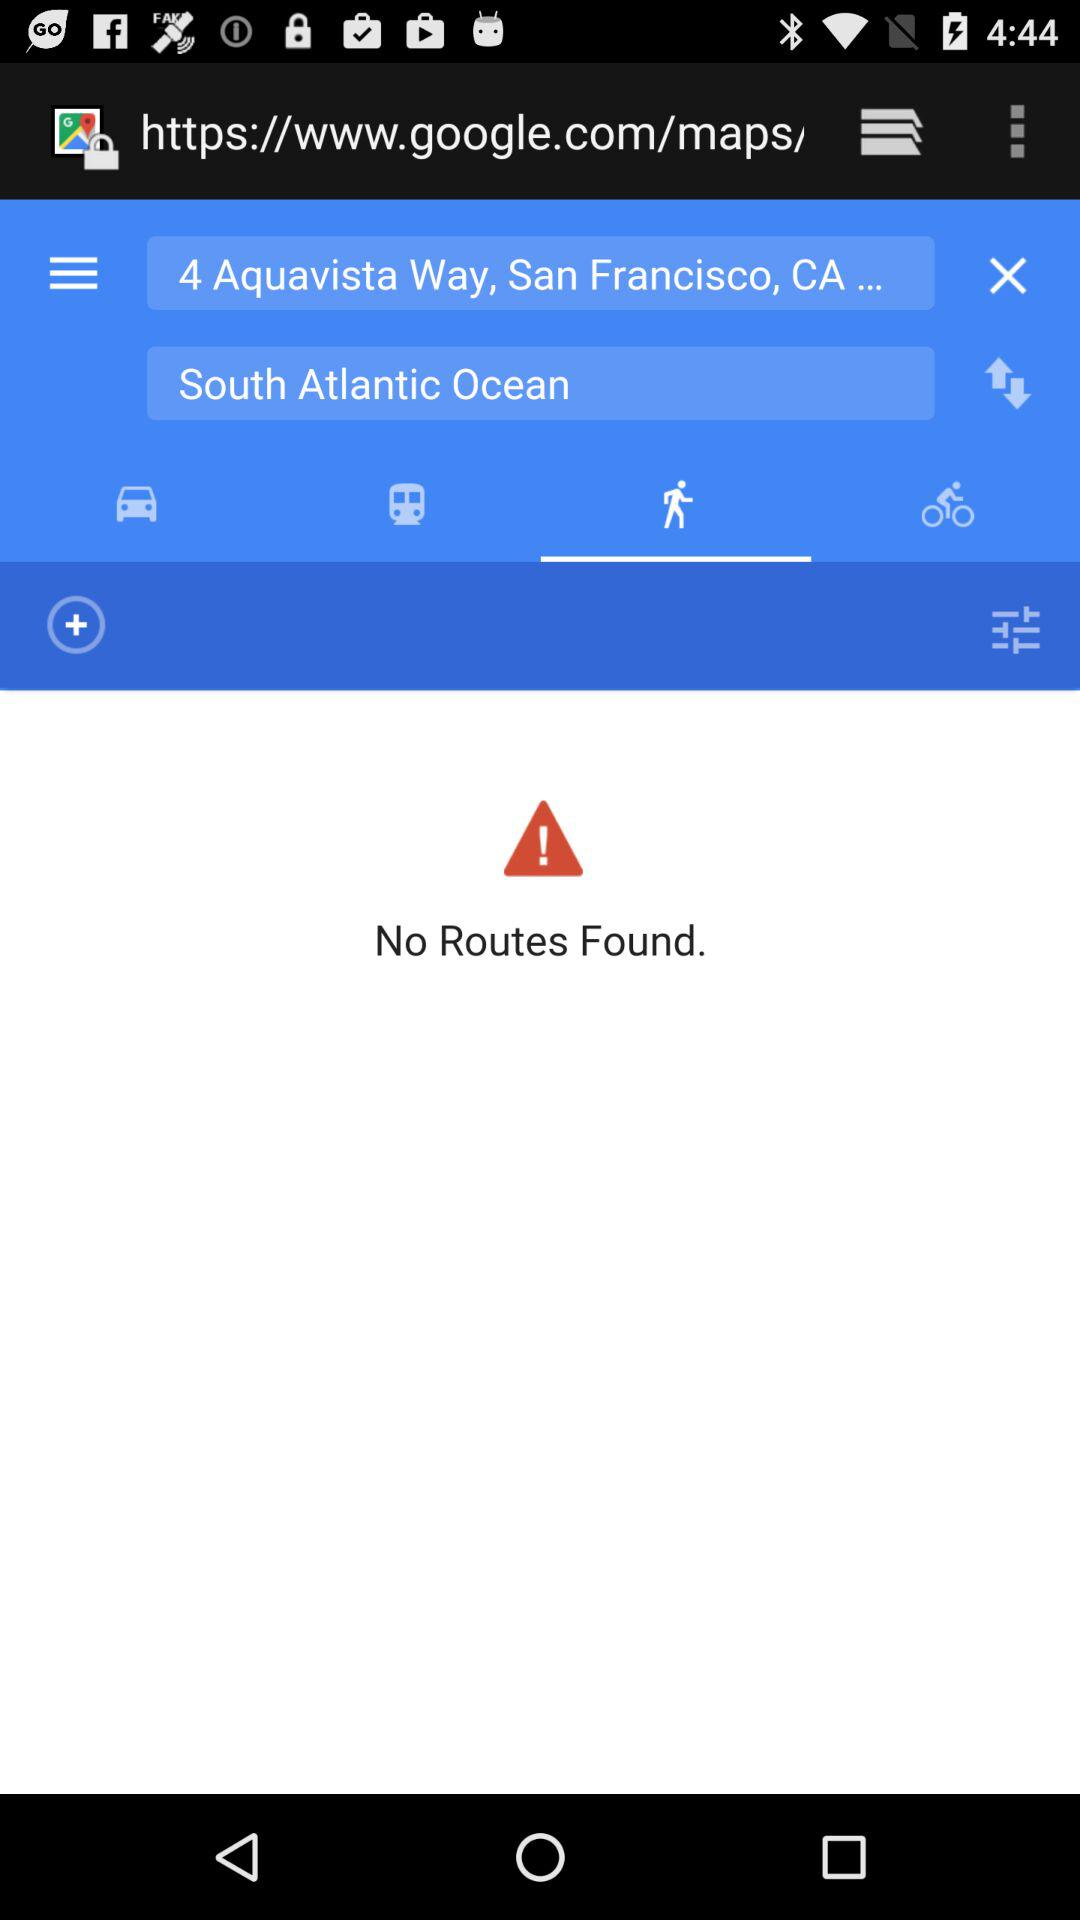Which tab is selected? The selected tab is "Walk". 